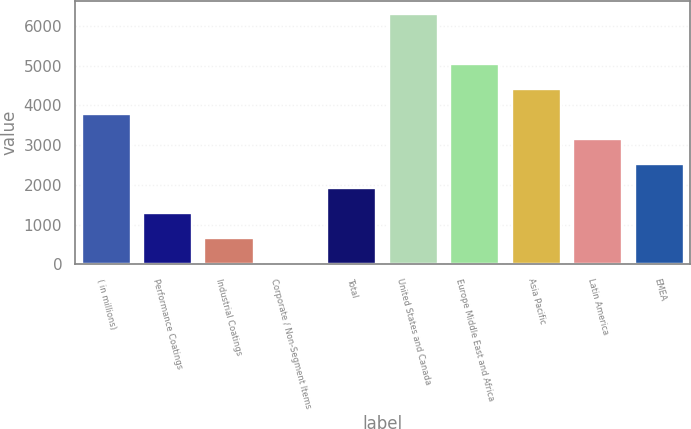<chart> <loc_0><loc_0><loc_500><loc_500><bar_chart><fcel>( in millions)<fcel>Performance Coatings<fcel>Industrial Coatings<fcel>Corporate / Non-Segment Items<fcel>Total<fcel>United States and Canada<fcel>Europe Middle East and Africa<fcel>Asia Pacific<fcel>Latin America<fcel>EMEA<nl><fcel>3793.8<fcel>1280.6<fcel>652.3<fcel>24<fcel>1908.9<fcel>6307<fcel>5050.4<fcel>4422.1<fcel>3165.5<fcel>2537.2<nl></chart> 